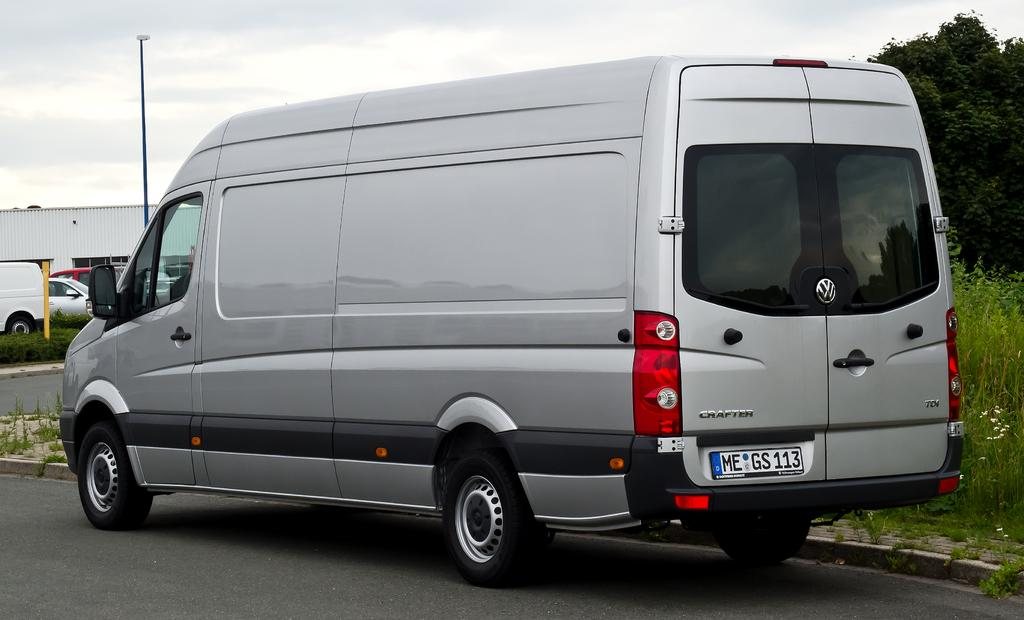<image>
Summarize the visual content of the image. A silver Volkswagon van is stopped on the side of the street near wildflowers. 